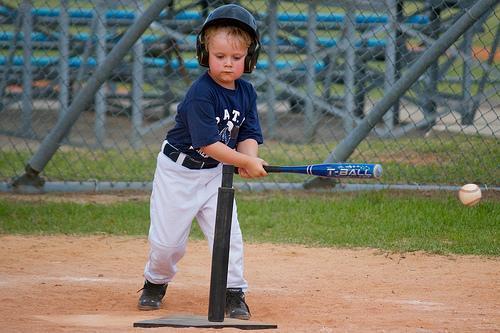How many kids playing in the field?
Give a very brief answer. 1. 